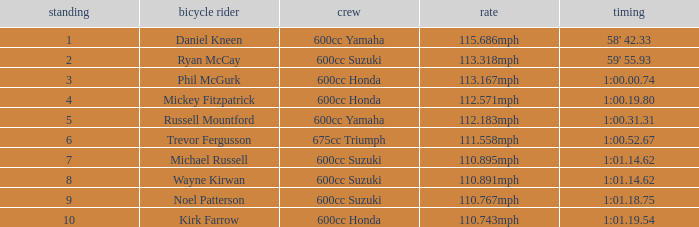What time has phil mcgurk as the rider? 1:00.00.74. 